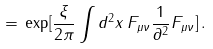<formula> <loc_0><loc_0><loc_500><loc_500>\, = \, \exp [ \frac { \xi } { 2 \pi } \int d ^ { 2 } x \, F _ { \mu \nu } \frac { 1 } { \partial ^ { 2 } } F _ { \mu \nu } ] \, .</formula> 